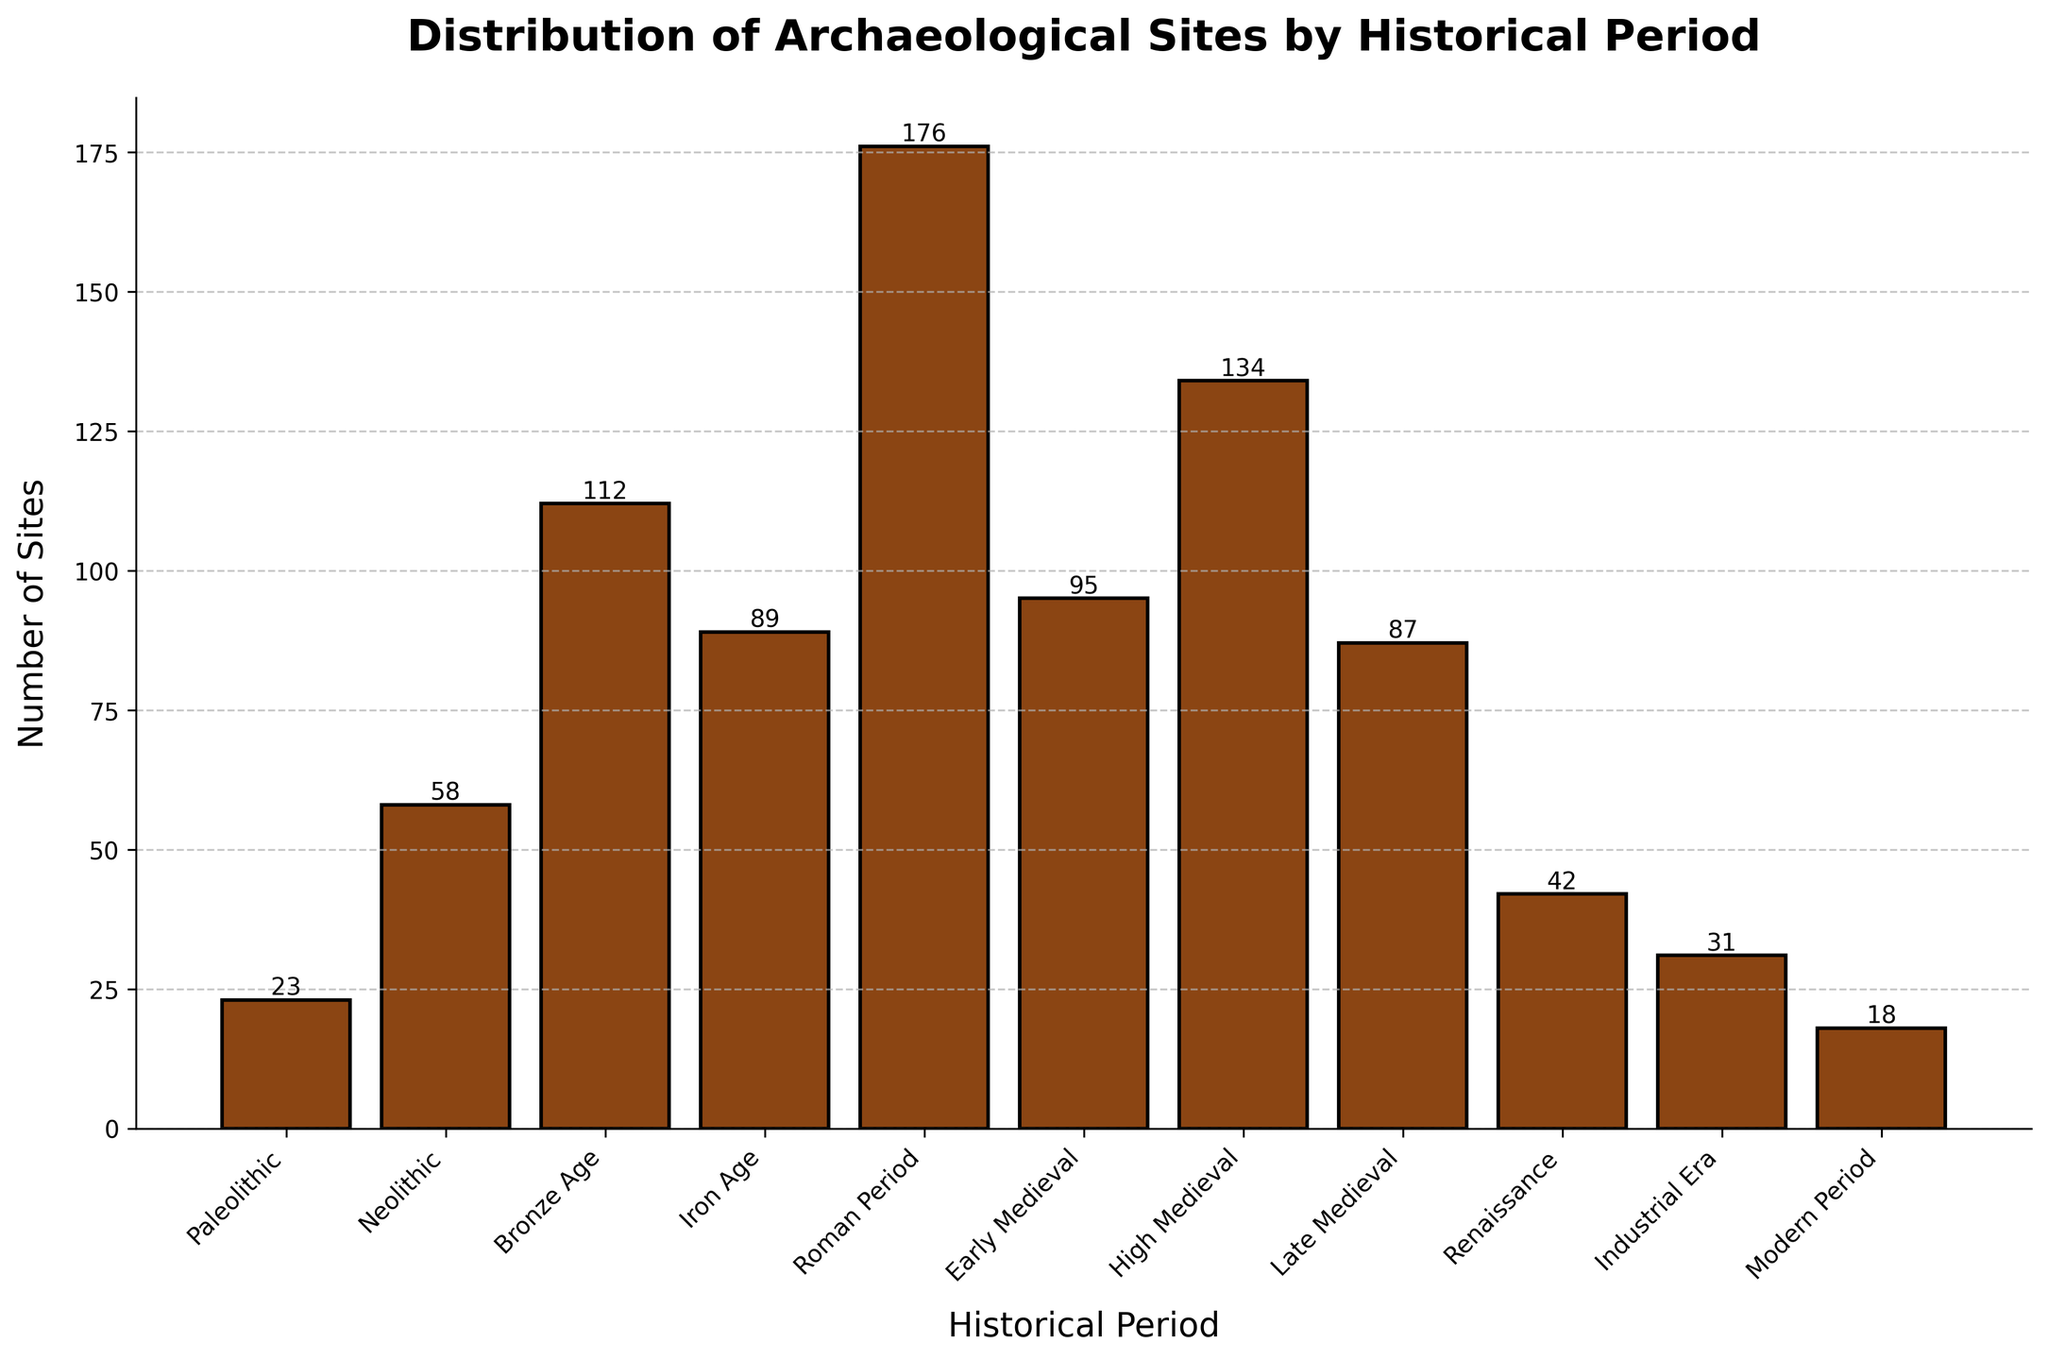Which historical period has the highest number of archaeological sites? To determine this, look for the tallest bar in the chart. The Roman Period has the tallest bar.
Answer: Roman Period What is the total number of archaeological sites documented for the Bronze Age and the Iron Age? Add the number of sites for both periods: Bronze Age (112) + Iron Age (89) = 201.
Answer: 201 During which period were there fewer sites: the Renaissance or the Industrial Era? Compare the heights of the bars for these periods; the Renaissance has 42 sites and the Industrial Era has 31 sites. Therefore, the Industrial Era has fewer.
Answer: Industrial Era What is the difference in the number of sites between the High Medieval and Early Medieval periods? Subtract the number of sites in the Early Medieval period from the High Medieval period: High Medieval (134) - Early Medieval (95) = 39.
Answer: 39 Between which two consecutive historical periods is the largest increase in the number of archaeological sites observed? Find the largest difference in heights of consecutive bars: The largest increase is from the Neolithic (58) to the Bronze Age (112), which is 112 - 58 = 54.
Answer: Neolithic to Bronze Age What percentage of the total number of archaeological sites does the Roman Period account for? Calculate the total number of sites and the percentage for the Roman Period. Total = 865, Roman Period = 176. Percentage = (176 / 865) * 100 ≈ 20.35%.
Answer: ~20.35% Which three periods have the smallest number of archaeological sites, and how many sites are there for each? Identify the three shortest bars: Modern Period (18), Paleolithic (23), and Industrial Era (31).
Answer: Modern Period: 18, Paleolithic: 23, Industrial Era: 31 How many archaeological sites are there in total from the Renaissance to the Modern Period inclusive? Add up the number of sites for these periods: Renaissance (42) + Industrial Era (31) + Modern Period (18) = 91.
Answer: 91 Is the number of sites in the High Medieval period greater than the total number of sites in the Paleolithic and Neolithic periods combined? Calculate and compare: Paleolithic (23) + Neolithic (58) = 81. High Medieval (134) is indeed greater than 81.
Answer: Yes How many more archaeological sites are there in the Roman Period compared to the Paleolithic and Neolithic periods combined? Calculate each sum and then the difference: Roman Period (176) - (Paleolithic (23) + Neolithic (58)) = 176 - 81 = 95.
Answer: 95 